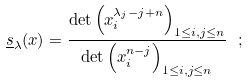<formula> <loc_0><loc_0><loc_500><loc_500>\underline { s } _ { \lambda } ( x ) = \frac { \det \left ( x _ { i } ^ { \lambda _ { j } - j + n } \right ) _ { 1 \leq i , j \leq n } } { \det \left ( x _ { i } ^ { n - j } \right ) _ { 1 \leq i , j \leq n } } \ ;</formula> 